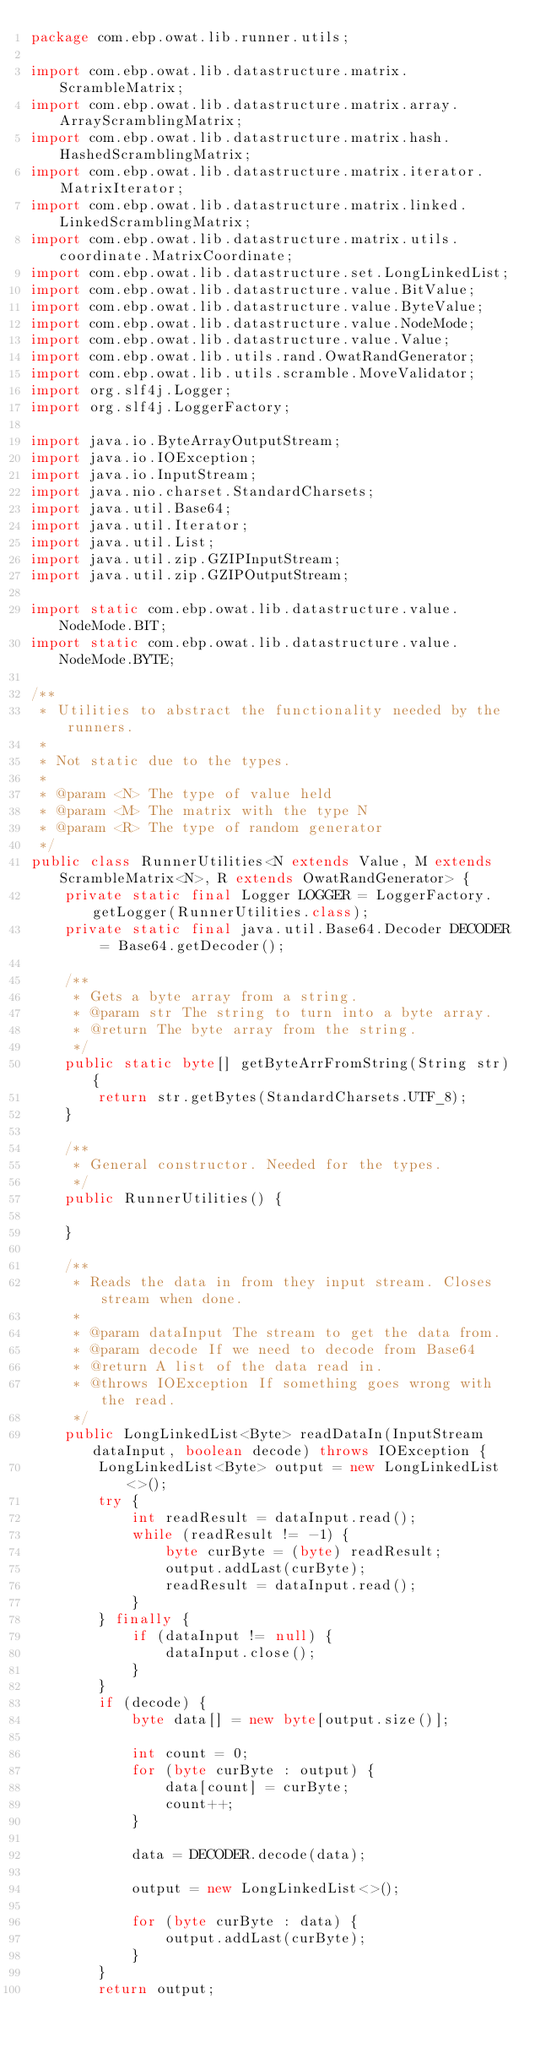<code> <loc_0><loc_0><loc_500><loc_500><_Java_>package com.ebp.owat.lib.runner.utils;

import com.ebp.owat.lib.datastructure.matrix.ScrambleMatrix;
import com.ebp.owat.lib.datastructure.matrix.array.ArrayScramblingMatrix;
import com.ebp.owat.lib.datastructure.matrix.hash.HashedScramblingMatrix;
import com.ebp.owat.lib.datastructure.matrix.iterator.MatrixIterator;
import com.ebp.owat.lib.datastructure.matrix.linked.LinkedScramblingMatrix;
import com.ebp.owat.lib.datastructure.matrix.utils.coordinate.MatrixCoordinate;
import com.ebp.owat.lib.datastructure.set.LongLinkedList;
import com.ebp.owat.lib.datastructure.value.BitValue;
import com.ebp.owat.lib.datastructure.value.ByteValue;
import com.ebp.owat.lib.datastructure.value.NodeMode;
import com.ebp.owat.lib.datastructure.value.Value;
import com.ebp.owat.lib.utils.rand.OwatRandGenerator;
import com.ebp.owat.lib.utils.scramble.MoveValidator;
import org.slf4j.Logger;
import org.slf4j.LoggerFactory;

import java.io.ByteArrayOutputStream;
import java.io.IOException;
import java.io.InputStream;
import java.nio.charset.StandardCharsets;
import java.util.Base64;
import java.util.Iterator;
import java.util.List;
import java.util.zip.GZIPInputStream;
import java.util.zip.GZIPOutputStream;

import static com.ebp.owat.lib.datastructure.value.NodeMode.BIT;
import static com.ebp.owat.lib.datastructure.value.NodeMode.BYTE;

/**
 * Utilities to abstract the functionality needed by the runners.
 *
 * Not static due to the types.
 *
 * @param <N> The type of value held
 * @param <M> The matrix with the type N
 * @param <R> The type of random generator
 */
public class RunnerUtilities<N extends Value, M extends ScrambleMatrix<N>, R extends OwatRandGenerator> {
	private static final Logger LOGGER = LoggerFactory.getLogger(RunnerUtilities.class);
	private static final java.util.Base64.Decoder DECODER = Base64.getDecoder();

	/**
	 * Gets a byte array from a string.
	 * @param str The string to turn into a byte array.
	 * @return The byte array from the string.
	 */
	public static byte[] getByteArrFromString(String str){
		return str.getBytes(StandardCharsets.UTF_8);
	}

	/**
	 * General constructor. Needed for the types.
	 */
	public RunnerUtilities() {

	}

	/**
	 * Reads the data in from they input stream. Closes stream when done.
	 *
	 * @param dataInput The stream to get the data from.
	 * @param decode If we need to decode from Base64
	 * @return A list of the data read in.
	 * @throws IOException If something goes wrong with the read.
	 */
	public LongLinkedList<Byte> readDataIn(InputStream dataInput, boolean decode) throws IOException {
		LongLinkedList<Byte> output = new LongLinkedList<>();
		try {
			int readResult = dataInput.read();
			while (readResult != -1) {
				byte curByte = (byte) readResult;
				output.addLast(curByte);
				readResult = dataInput.read();
			}
		} finally {
			if (dataInput != null) {
				dataInput.close();
			}
		}
		if (decode) {
			byte data[] = new byte[output.size()];

			int count = 0;
			for (byte curByte : output) {
				data[count] = curByte;
				count++;
			}

			data = DECODER.decode(data);

			output = new LongLinkedList<>();

			for (byte curByte : data) {
				output.addLast(curByte);
			}
		}
		return output;</code> 